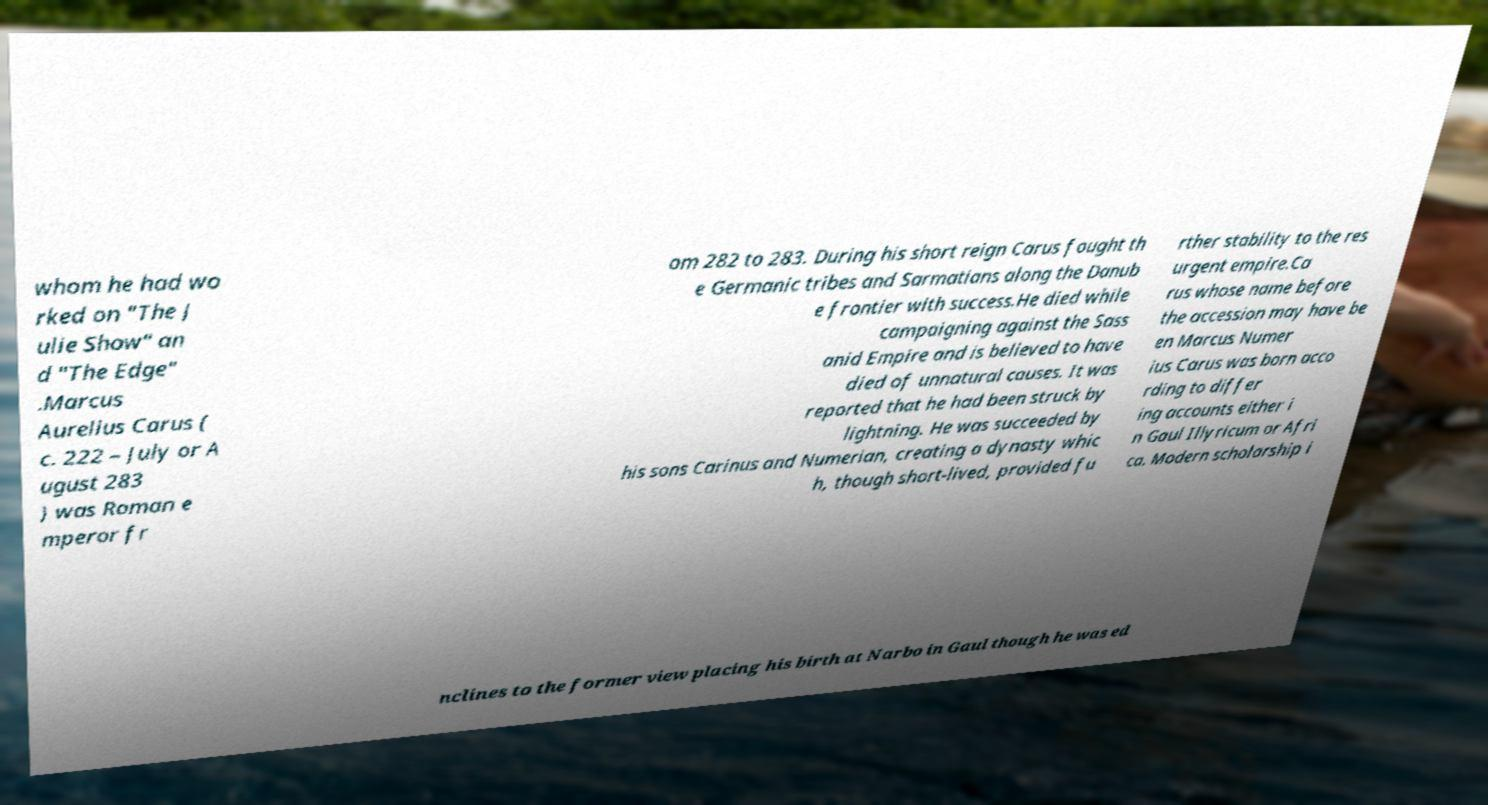There's text embedded in this image that I need extracted. Can you transcribe it verbatim? whom he had wo rked on "The J ulie Show" an d "The Edge" .Marcus Aurelius Carus ( c. 222 – July or A ugust 283 ) was Roman e mperor fr om 282 to 283. During his short reign Carus fought th e Germanic tribes and Sarmatians along the Danub e frontier with success.He died while campaigning against the Sass anid Empire and is believed to have died of unnatural causes. It was reported that he had been struck by lightning. He was succeeded by his sons Carinus and Numerian, creating a dynasty whic h, though short-lived, provided fu rther stability to the res urgent empire.Ca rus whose name before the accession may have be en Marcus Numer ius Carus was born acco rding to differ ing accounts either i n Gaul Illyricum or Afri ca. Modern scholarship i nclines to the former view placing his birth at Narbo in Gaul though he was ed 